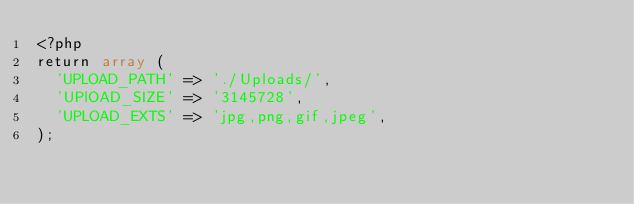<code> <loc_0><loc_0><loc_500><loc_500><_PHP_><?php
return array (
  'UPLOAD_PATH' => './Uploads/',
  'UPlOAD_SIZE' => '3145728',
  'UPLOAD_EXTS' => 'jpg,png,gif,jpeg',
); </code> 